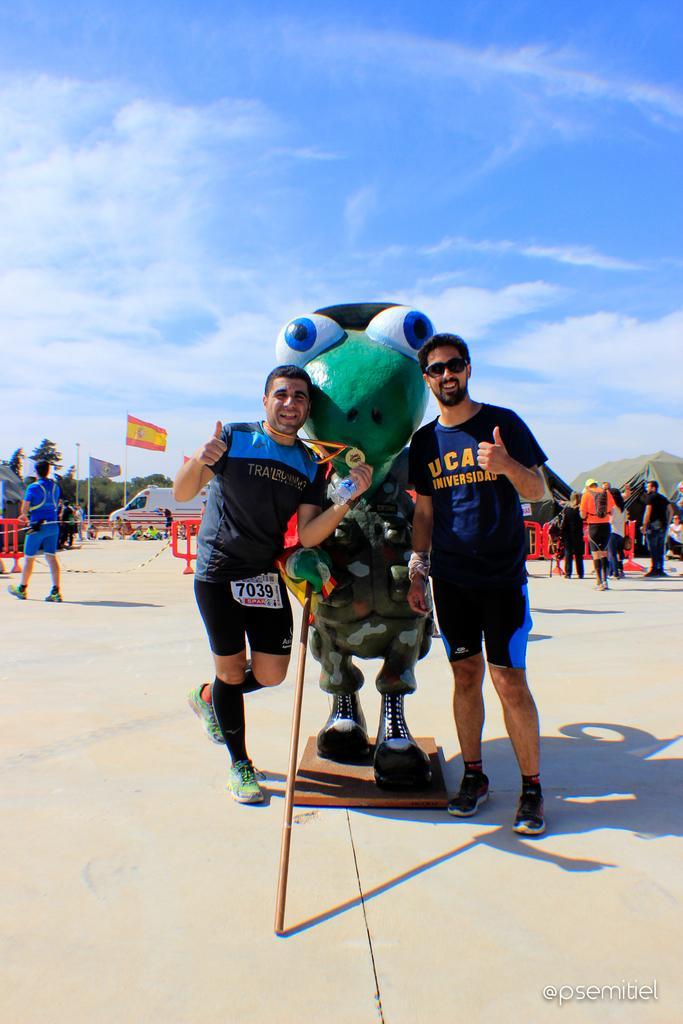Please provide a concise description of this image. In this image in the center there is one toy, and there are two people standing and smiling. And in the background there are group of people, tents, poles, flags, vehicle, trees, and some objects. At the bottom there is a walkway, and at the top there is sky. 